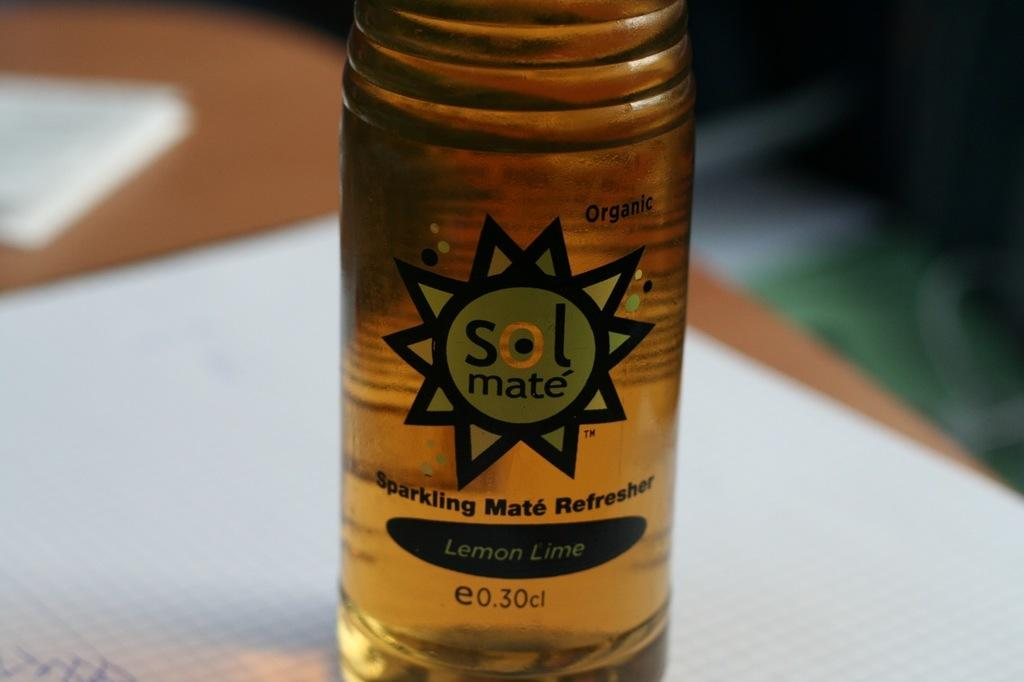<image>
Offer a succinct explanation of the picture presented. The sparkling beverage is flavoured with lemon and lime. 